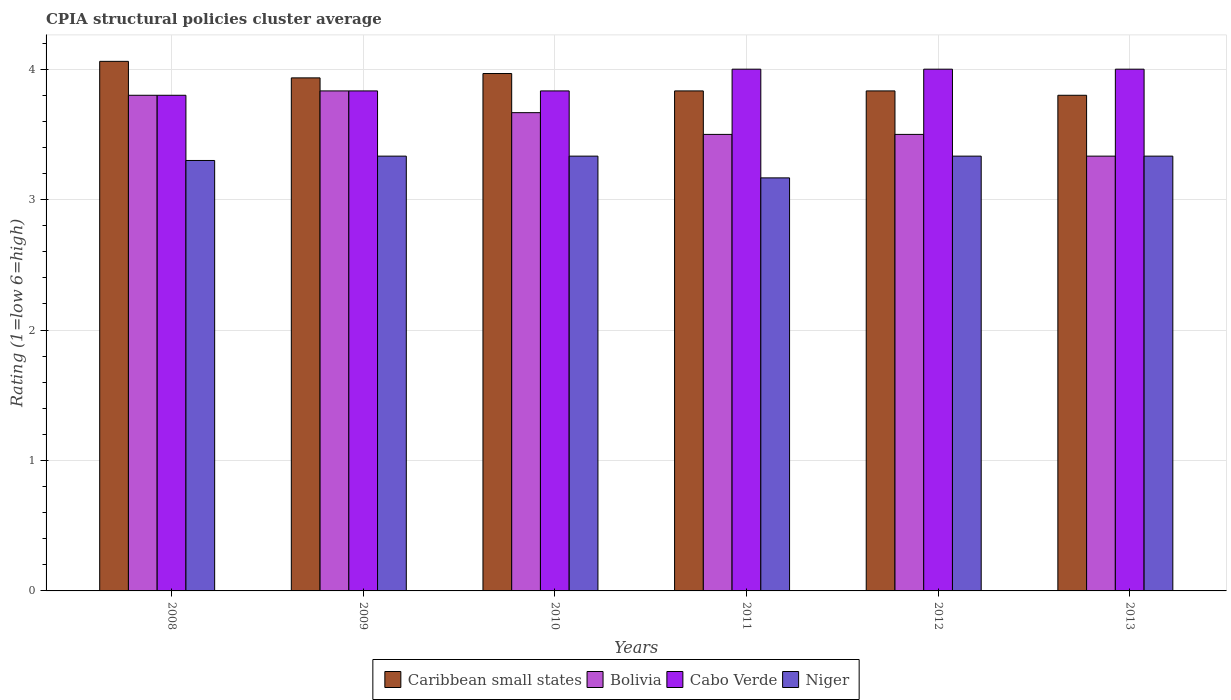How many different coloured bars are there?
Provide a short and direct response. 4. How many groups of bars are there?
Your answer should be compact. 6. Are the number of bars on each tick of the X-axis equal?
Keep it short and to the point. Yes. What is the label of the 3rd group of bars from the left?
Provide a short and direct response. 2010. In how many cases, is the number of bars for a given year not equal to the number of legend labels?
Your response must be concise. 0. What is the CPIA rating in Caribbean small states in 2011?
Your answer should be compact. 3.83. Across all years, what is the maximum CPIA rating in Niger?
Keep it short and to the point. 3.33. Across all years, what is the minimum CPIA rating in Bolivia?
Provide a short and direct response. 3.33. In which year was the CPIA rating in Caribbean small states maximum?
Keep it short and to the point. 2008. In which year was the CPIA rating in Caribbean small states minimum?
Your answer should be very brief. 2013. What is the total CPIA rating in Bolivia in the graph?
Your response must be concise. 21.63. What is the difference between the CPIA rating in Niger in 2008 and that in 2012?
Provide a succinct answer. -0.03. What is the difference between the CPIA rating in Caribbean small states in 2010 and the CPIA rating in Cabo Verde in 2013?
Your answer should be very brief. -0.03. What is the average CPIA rating in Bolivia per year?
Provide a succinct answer. 3.61. Is the CPIA rating in Caribbean small states in 2012 less than that in 2013?
Give a very brief answer. No. What is the difference between the highest and the lowest CPIA rating in Niger?
Make the answer very short. 0.17. In how many years, is the CPIA rating in Bolivia greater than the average CPIA rating in Bolivia taken over all years?
Your answer should be very brief. 3. Is the sum of the CPIA rating in Cabo Verde in 2010 and 2013 greater than the maximum CPIA rating in Niger across all years?
Your answer should be compact. Yes. What does the 2nd bar from the right in 2008 represents?
Your answer should be compact. Cabo Verde. Are all the bars in the graph horizontal?
Your answer should be very brief. No. Are the values on the major ticks of Y-axis written in scientific E-notation?
Ensure brevity in your answer.  No. Does the graph contain any zero values?
Give a very brief answer. No. How are the legend labels stacked?
Offer a terse response. Horizontal. What is the title of the graph?
Your response must be concise. CPIA structural policies cluster average. Does "Gabon" appear as one of the legend labels in the graph?
Provide a short and direct response. No. What is the label or title of the X-axis?
Provide a short and direct response. Years. What is the Rating (1=low 6=high) of Caribbean small states in 2008?
Your response must be concise. 4.06. What is the Rating (1=low 6=high) in Bolivia in 2008?
Keep it short and to the point. 3.8. What is the Rating (1=low 6=high) of Niger in 2008?
Your response must be concise. 3.3. What is the Rating (1=low 6=high) in Caribbean small states in 2009?
Provide a short and direct response. 3.93. What is the Rating (1=low 6=high) in Bolivia in 2009?
Offer a terse response. 3.83. What is the Rating (1=low 6=high) of Cabo Verde in 2009?
Offer a terse response. 3.83. What is the Rating (1=low 6=high) in Niger in 2009?
Your response must be concise. 3.33. What is the Rating (1=low 6=high) of Caribbean small states in 2010?
Your answer should be very brief. 3.97. What is the Rating (1=low 6=high) of Bolivia in 2010?
Provide a succinct answer. 3.67. What is the Rating (1=low 6=high) of Cabo Verde in 2010?
Ensure brevity in your answer.  3.83. What is the Rating (1=low 6=high) in Niger in 2010?
Your answer should be very brief. 3.33. What is the Rating (1=low 6=high) of Caribbean small states in 2011?
Keep it short and to the point. 3.83. What is the Rating (1=low 6=high) in Cabo Verde in 2011?
Give a very brief answer. 4. What is the Rating (1=low 6=high) of Niger in 2011?
Offer a terse response. 3.17. What is the Rating (1=low 6=high) in Caribbean small states in 2012?
Ensure brevity in your answer.  3.83. What is the Rating (1=low 6=high) of Niger in 2012?
Offer a terse response. 3.33. What is the Rating (1=low 6=high) of Caribbean small states in 2013?
Make the answer very short. 3.8. What is the Rating (1=low 6=high) in Bolivia in 2013?
Your answer should be compact. 3.33. What is the Rating (1=low 6=high) in Cabo Verde in 2013?
Provide a short and direct response. 4. What is the Rating (1=low 6=high) in Niger in 2013?
Keep it short and to the point. 3.33. Across all years, what is the maximum Rating (1=low 6=high) of Caribbean small states?
Make the answer very short. 4.06. Across all years, what is the maximum Rating (1=low 6=high) of Bolivia?
Give a very brief answer. 3.83. Across all years, what is the maximum Rating (1=low 6=high) in Cabo Verde?
Give a very brief answer. 4. Across all years, what is the maximum Rating (1=low 6=high) of Niger?
Give a very brief answer. 3.33. Across all years, what is the minimum Rating (1=low 6=high) in Bolivia?
Give a very brief answer. 3.33. Across all years, what is the minimum Rating (1=low 6=high) in Cabo Verde?
Your answer should be compact. 3.8. Across all years, what is the minimum Rating (1=low 6=high) of Niger?
Your answer should be compact. 3.17. What is the total Rating (1=low 6=high) in Caribbean small states in the graph?
Ensure brevity in your answer.  23.43. What is the total Rating (1=low 6=high) of Bolivia in the graph?
Offer a terse response. 21.63. What is the total Rating (1=low 6=high) in Cabo Verde in the graph?
Keep it short and to the point. 23.47. What is the total Rating (1=low 6=high) in Niger in the graph?
Ensure brevity in your answer.  19.8. What is the difference between the Rating (1=low 6=high) in Caribbean small states in 2008 and that in 2009?
Offer a terse response. 0.13. What is the difference between the Rating (1=low 6=high) of Bolivia in 2008 and that in 2009?
Make the answer very short. -0.03. What is the difference between the Rating (1=low 6=high) of Cabo Verde in 2008 and that in 2009?
Keep it short and to the point. -0.03. What is the difference between the Rating (1=low 6=high) in Niger in 2008 and that in 2009?
Keep it short and to the point. -0.03. What is the difference between the Rating (1=low 6=high) in Caribbean small states in 2008 and that in 2010?
Your answer should be compact. 0.09. What is the difference between the Rating (1=low 6=high) in Bolivia in 2008 and that in 2010?
Your response must be concise. 0.13. What is the difference between the Rating (1=low 6=high) of Cabo Verde in 2008 and that in 2010?
Your answer should be very brief. -0.03. What is the difference between the Rating (1=low 6=high) of Niger in 2008 and that in 2010?
Give a very brief answer. -0.03. What is the difference between the Rating (1=low 6=high) of Caribbean small states in 2008 and that in 2011?
Offer a very short reply. 0.23. What is the difference between the Rating (1=low 6=high) in Bolivia in 2008 and that in 2011?
Provide a short and direct response. 0.3. What is the difference between the Rating (1=low 6=high) of Niger in 2008 and that in 2011?
Ensure brevity in your answer.  0.13. What is the difference between the Rating (1=low 6=high) in Caribbean small states in 2008 and that in 2012?
Keep it short and to the point. 0.23. What is the difference between the Rating (1=low 6=high) of Bolivia in 2008 and that in 2012?
Provide a succinct answer. 0.3. What is the difference between the Rating (1=low 6=high) of Niger in 2008 and that in 2012?
Offer a terse response. -0.03. What is the difference between the Rating (1=low 6=high) of Caribbean small states in 2008 and that in 2013?
Make the answer very short. 0.26. What is the difference between the Rating (1=low 6=high) of Bolivia in 2008 and that in 2013?
Give a very brief answer. 0.47. What is the difference between the Rating (1=low 6=high) of Cabo Verde in 2008 and that in 2013?
Your answer should be compact. -0.2. What is the difference between the Rating (1=low 6=high) in Niger in 2008 and that in 2013?
Provide a short and direct response. -0.03. What is the difference between the Rating (1=low 6=high) of Caribbean small states in 2009 and that in 2010?
Give a very brief answer. -0.03. What is the difference between the Rating (1=low 6=high) of Bolivia in 2009 and that in 2010?
Offer a terse response. 0.17. What is the difference between the Rating (1=low 6=high) in Cabo Verde in 2009 and that in 2010?
Your answer should be very brief. 0. What is the difference between the Rating (1=low 6=high) in Niger in 2009 and that in 2011?
Provide a short and direct response. 0.17. What is the difference between the Rating (1=low 6=high) of Bolivia in 2009 and that in 2012?
Your answer should be compact. 0.33. What is the difference between the Rating (1=low 6=high) in Caribbean small states in 2009 and that in 2013?
Provide a short and direct response. 0.13. What is the difference between the Rating (1=low 6=high) in Cabo Verde in 2009 and that in 2013?
Offer a very short reply. -0.17. What is the difference between the Rating (1=low 6=high) of Caribbean small states in 2010 and that in 2011?
Your answer should be compact. 0.13. What is the difference between the Rating (1=low 6=high) in Bolivia in 2010 and that in 2011?
Make the answer very short. 0.17. What is the difference between the Rating (1=low 6=high) of Caribbean small states in 2010 and that in 2012?
Provide a short and direct response. 0.13. What is the difference between the Rating (1=low 6=high) of Bolivia in 2010 and that in 2012?
Your response must be concise. 0.17. What is the difference between the Rating (1=low 6=high) of Niger in 2010 and that in 2012?
Provide a succinct answer. 0. What is the difference between the Rating (1=low 6=high) in Caribbean small states in 2010 and that in 2013?
Offer a terse response. 0.17. What is the difference between the Rating (1=low 6=high) of Bolivia in 2010 and that in 2013?
Offer a very short reply. 0.33. What is the difference between the Rating (1=low 6=high) of Caribbean small states in 2011 and that in 2013?
Give a very brief answer. 0.03. What is the difference between the Rating (1=low 6=high) of Bolivia in 2011 and that in 2013?
Give a very brief answer. 0.17. What is the difference between the Rating (1=low 6=high) in Bolivia in 2012 and that in 2013?
Your answer should be compact. 0.17. What is the difference between the Rating (1=low 6=high) of Cabo Verde in 2012 and that in 2013?
Your response must be concise. 0. What is the difference between the Rating (1=low 6=high) of Niger in 2012 and that in 2013?
Give a very brief answer. 0. What is the difference between the Rating (1=low 6=high) of Caribbean small states in 2008 and the Rating (1=low 6=high) of Bolivia in 2009?
Your response must be concise. 0.23. What is the difference between the Rating (1=low 6=high) of Caribbean small states in 2008 and the Rating (1=low 6=high) of Cabo Verde in 2009?
Keep it short and to the point. 0.23. What is the difference between the Rating (1=low 6=high) of Caribbean small states in 2008 and the Rating (1=low 6=high) of Niger in 2009?
Your answer should be very brief. 0.73. What is the difference between the Rating (1=low 6=high) of Bolivia in 2008 and the Rating (1=low 6=high) of Cabo Verde in 2009?
Your answer should be very brief. -0.03. What is the difference between the Rating (1=low 6=high) of Bolivia in 2008 and the Rating (1=low 6=high) of Niger in 2009?
Provide a succinct answer. 0.47. What is the difference between the Rating (1=low 6=high) in Cabo Verde in 2008 and the Rating (1=low 6=high) in Niger in 2009?
Provide a succinct answer. 0.47. What is the difference between the Rating (1=low 6=high) in Caribbean small states in 2008 and the Rating (1=low 6=high) in Bolivia in 2010?
Ensure brevity in your answer.  0.39. What is the difference between the Rating (1=low 6=high) in Caribbean small states in 2008 and the Rating (1=low 6=high) in Cabo Verde in 2010?
Ensure brevity in your answer.  0.23. What is the difference between the Rating (1=low 6=high) of Caribbean small states in 2008 and the Rating (1=low 6=high) of Niger in 2010?
Give a very brief answer. 0.73. What is the difference between the Rating (1=low 6=high) in Bolivia in 2008 and the Rating (1=low 6=high) in Cabo Verde in 2010?
Ensure brevity in your answer.  -0.03. What is the difference between the Rating (1=low 6=high) of Bolivia in 2008 and the Rating (1=low 6=high) of Niger in 2010?
Your answer should be compact. 0.47. What is the difference between the Rating (1=low 6=high) of Cabo Verde in 2008 and the Rating (1=low 6=high) of Niger in 2010?
Your answer should be very brief. 0.47. What is the difference between the Rating (1=low 6=high) of Caribbean small states in 2008 and the Rating (1=low 6=high) of Bolivia in 2011?
Your answer should be compact. 0.56. What is the difference between the Rating (1=low 6=high) in Caribbean small states in 2008 and the Rating (1=low 6=high) in Cabo Verde in 2011?
Keep it short and to the point. 0.06. What is the difference between the Rating (1=low 6=high) in Caribbean small states in 2008 and the Rating (1=low 6=high) in Niger in 2011?
Provide a short and direct response. 0.89. What is the difference between the Rating (1=low 6=high) of Bolivia in 2008 and the Rating (1=low 6=high) of Cabo Verde in 2011?
Your response must be concise. -0.2. What is the difference between the Rating (1=low 6=high) of Bolivia in 2008 and the Rating (1=low 6=high) of Niger in 2011?
Give a very brief answer. 0.63. What is the difference between the Rating (1=low 6=high) of Cabo Verde in 2008 and the Rating (1=low 6=high) of Niger in 2011?
Give a very brief answer. 0.63. What is the difference between the Rating (1=low 6=high) of Caribbean small states in 2008 and the Rating (1=low 6=high) of Bolivia in 2012?
Provide a succinct answer. 0.56. What is the difference between the Rating (1=low 6=high) of Caribbean small states in 2008 and the Rating (1=low 6=high) of Niger in 2012?
Make the answer very short. 0.73. What is the difference between the Rating (1=low 6=high) in Bolivia in 2008 and the Rating (1=low 6=high) in Cabo Verde in 2012?
Offer a very short reply. -0.2. What is the difference between the Rating (1=low 6=high) in Bolivia in 2008 and the Rating (1=low 6=high) in Niger in 2012?
Ensure brevity in your answer.  0.47. What is the difference between the Rating (1=low 6=high) of Cabo Verde in 2008 and the Rating (1=low 6=high) of Niger in 2012?
Your answer should be compact. 0.47. What is the difference between the Rating (1=low 6=high) of Caribbean small states in 2008 and the Rating (1=low 6=high) of Bolivia in 2013?
Give a very brief answer. 0.73. What is the difference between the Rating (1=low 6=high) of Caribbean small states in 2008 and the Rating (1=low 6=high) of Cabo Verde in 2013?
Make the answer very short. 0.06. What is the difference between the Rating (1=low 6=high) in Caribbean small states in 2008 and the Rating (1=low 6=high) in Niger in 2013?
Your response must be concise. 0.73. What is the difference between the Rating (1=low 6=high) in Bolivia in 2008 and the Rating (1=low 6=high) in Niger in 2013?
Keep it short and to the point. 0.47. What is the difference between the Rating (1=low 6=high) of Cabo Verde in 2008 and the Rating (1=low 6=high) of Niger in 2013?
Offer a very short reply. 0.47. What is the difference between the Rating (1=low 6=high) in Caribbean small states in 2009 and the Rating (1=low 6=high) in Bolivia in 2010?
Keep it short and to the point. 0.27. What is the difference between the Rating (1=low 6=high) of Bolivia in 2009 and the Rating (1=low 6=high) of Cabo Verde in 2010?
Ensure brevity in your answer.  0. What is the difference between the Rating (1=low 6=high) in Cabo Verde in 2009 and the Rating (1=low 6=high) in Niger in 2010?
Your answer should be very brief. 0.5. What is the difference between the Rating (1=low 6=high) of Caribbean small states in 2009 and the Rating (1=low 6=high) of Bolivia in 2011?
Your answer should be very brief. 0.43. What is the difference between the Rating (1=low 6=high) of Caribbean small states in 2009 and the Rating (1=low 6=high) of Cabo Verde in 2011?
Offer a terse response. -0.07. What is the difference between the Rating (1=low 6=high) in Caribbean small states in 2009 and the Rating (1=low 6=high) in Niger in 2011?
Give a very brief answer. 0.77. What is the difference between the Rating (1=low 6=high) in Bolivia in 2009 and the Rating (1=low 6=high) in Cabo Verde in 2011?
Keep it short and to the point. -0.17. What is the difference between the Rating (1=low 6=high) in Caribbean small states in 2009 and the Rating (1=low 6=high) in Bolivia in 2012?
Provide a short and direct response. 0.43. What is the difference between the Rating (1=low 6=high) in Caribbean small states in 2009 and the Rating (1=low 6=high) in Cabo Verde in 2012?
Your response must be concise. -0.07. What is the difference between the Rating (1=low 6=high) in Caribbean small states in 2009 and the Rating (1=low 6=high) in Niger in 2012?
Your answer should be very brief. 0.6. What is the difference between the Rating (1=low 6=high) in Bolivia in 2009 and the Rating (1=low 6=high) in Cabo Verde in 2012?
Provide a succinct answer. -0.17. What is the difference between the Rating (1=low 6=high) of Bolivia in 2009 and the Rating (1=low 6=high) of Niger in 2012?
Offer a very short reply. 0.5. What is the difference between the Rating (1=low 6=high) in Cabo Verde in 2009 and the Rating (1=low 6=high) in Niger in 2012?
Provide a short and direct response. 0.5. What is the difference between the Rating (1=low 6=high) of Caribbean small states in 2009 and the Rating (1=low 6=high) of Bolivia in 2013?
Your answer should be very brief. 0.6. What is the difference between the Rating (1=low 6=high) in Caribbean small states in 2009 and the Rating (1=low 6=high) in Cabo Verde in 2013?
Make the answer very short. -0.07. What is the difference between the Rating (1=low 6=high) in Cabo Verde in 2009 and the Rating (1=low 6=high) in Niger in 2013?
Your response must be concise. 0.5. What is the difference between the Rating (1=low 6=high) of Caribbean small states in 2010 and the Rating (1=low 6=high) of Bolivia in 2011?
Offer a very short reply. 0.47. What is the difference between the Rating (1=low 6=high) in Caribbean small states in 2010 and the Rating (1=low 6=high) in Cabo Verde in 2011?
Ensure brevity in your answer.  -0.03. What is the difference between the Rating (1=low 6=high) in Caribbean small states in 2010 and the Rating (1=low 6=high) in Niger in 2011?
Give a very brief answer. 0.8. What is the difference between the Rating (1=low 6=high) in Bolivia in 2010 and the Rating (1=low 6=high) in Niger in 2011?
Your response must be concise. 0.5. What is the difference between the Rating (1=low 6=high) of Caribbean small states in 2010 and the Rating (1=low 6=high) of Bolivia in 2012?
Your answer should be very brief. 0.47. What is the difference between the Rating (1=low 6=high) in Caribbean small states in 2010 and the Rating (1=low 6=high) in Cabo Verde in 2012?
Ensure brevity in your answer.  -0.03. What is the difference between the Rating (1=low 6=high) of Caribbean small states in 2010 and the Rating (1=low 6=high) of Niger in 2012?
Offer a very short reply. 0.63. What is the difference between the Rating (1=low 6=high) in Bolivia in 2010 and the Rating (1=low 6=high) in Cabo Verde in 2012?
Keep it short and to the point. -0.33. What is the difference between the Rating (1=low 6=high) in Cabo Verde in 2010 and the Rating (1=low 6=high) in Niger in 2012?
Your answer should be very brief. 0.5. What is the difference between the Rating (1=low 6=high) in Caribbean small states in 2010 and the Rating (1=low 6=high) in Bolivia in 2013?
Provide a succinct answer. 0.63. What is the difference between the Rating (1=low 6=high) of Caribbean small states in 2010 and the Rating (1=low 6=high) of Cabo Verde in 2013?
Ensure brevity in your answer.  -0.03. What is the difference between the Rating (1=low 6=high) of Caribbean small states in 2010 and the Rating (1=low 6=high) of Niger in 2013?
Ensure brevity in your answer.  0.63. What is the difference between the Rating (1=low 6=high) of Bolivia in 2010 and the Rating (1=low 6=high) of Cabo Verde in 2013?
Ensure brevity in your answer.  -0.33. What is the difference between the Rating (1=low 6=high) of Cabo Verde in 2010 and the Rating (1=low 6=high) of Niger in 2013?
Your answer should be very brief. 0.5. What is the difference between the Rating (1=low 6=high) in Caribbean small states in 2011 and the Rating (1=low 6=high) in Cabo Verde in 2012?
Give a very brief answer. -0.17. What is the difference between the Rating (1=low 6=high) in Bolivia in 2011 and the Rating (1=low 6=high) in Cabo Verde in 2012?
Offer a terse response. -0.5. What is the difference between the Rating (1=low 6=high) in Bolivia in 2011 and the Rating (1=low 6=high) in Niger in 2012?
Provide a succinct answer. 0.17. What is the difference between the Rating (1=low 6=high) of Cabo Verde in 2011 and the Rating (1=low 6=high) of Niger in 2012?
Your answer should be very brief. 0.67. What is the difference between the Rating (1=low 6=high) in Caribbean small states in 2011 and the Rating (1=low 6=high) in Bolivia in 2013?
Provide a short and direct response. 0.5. What is the difference between the Rating (1=low 6=high) in Cabo Verde in 2011 and the Rating (1=low 6=high) in Niger in 2013?
Provide a succinct answer. 0.67. What is the difference between the Rating (1=low 6=high) of Caribbean small states in 2012 and the Rating (1=low 6=high) of Niger in 2013?
Give a very brief answer. 0.5. What is the average Rating (1=low 6=high) in Caribbean small states per year?
Your answer should be very brief. 3.9. What is the average Rating (1=low 6=high) of Bolivia per year?
Make the answer very short. 3.61. What is the average Rating (1=low 6=high) of Cabo Verde per year?
Keep it short and to the point. 3.91. In the year 2008, what is the difference between the Rating (1=low 6=high) in Caribbean small states and Rating (1=low 6=high) in Bolivia?
Your answer should be very brief. 0.26. In the year 2008, what is the difference between the Rating (1=low 6=high) of Caribbean small states and Rating (1=low 6=high) of Cabo Verde?
Offer a very short reply. 0.26. In the year 2008, what is the difference between the Rating (1=low 6=high) of Caribbean small states and Rating (1=low 6=high) of Niger?
Offer a very short reply. 0.76. In the year 2008, what is the difference between the Rating (1=low 6=high) of Bolivia and Rating (1=low 6=high) of Niger?
Offer a very short reply. 0.5. In the year 2008, what is the difference between the Rating (1=low 6=high) in Cabo Verde and Rating (1=low 6=high) in Niger?
Give a very brief answer. 0.5. In the year 2009, what is the difference between the Rating (1=low 6=high) in Caribbean small states and Rating (1=low 6=high) in Bolivia?
Your response must be concise. 0.1. In the year 2009, what is the difference between the Rating (1=low 6=high) of Caribbean small states and Rating (1=low 6=high) of Cabo Verde?
Keep it short and to the point. 0.1. In the year 2009, what is the difference between the Rating (1=low 6=high) in Bolivia and Rating (1=low 6=high) in Cabo Verde?
Keep it short and to the point. 0. In the year 2009, what is the difference between the Rating (1=low 6=high) in Bolivia and Rating (1=low 6=high) in Niger?
Provide a succinct answer. 0.5. In the year 2009, what is the difference between the Rating (1=low 6=high) in Cabo Verde and Rating (1=low 6=high) in Niger?
Your answer should be very brief. 0.5. In the year 2010, what is the difference between the Rating (1=low 6=high) in Caribbean small states and Rating (1=low 6=high) in Bolivia?
Keep it short and to the point. 0.3. In the year 2010, what is the difference between the Rating (1=low 6=high) of Caribbean small states and Rating (1=low 6=high) of Cabo Verde?
Offer a very short reply. 0.13. In the year 2010, what is the difference between the Rating (1=low 6=high) of Caribbean small states and Rating (1=low 6=high) of Niger?
Offer a terse response. 0.63. In the year 2010, what is the difference between the Rating (1=low 6=high) in Bolivia and Rating (1=low 6=high) in Niger?
Provide a short and direct response. 0.33. In the year 2010, what is the difference between the Rating (1=low 6=high) in Cabo Verde and Rating (1=low 6=high) in Niger?
Provide a succinct answer. 0.5. In the year 2011, what is the difference between the Rating (1=low 6=high) in Caribbean small states and Rating (1=low 6=high) in Bolivia?
Provide a succinct answer. 0.33. In the year 2011, what is the difference between the Rating (1=low 6=high) in Caribbean small states and Rating (1=low 6=high) in Cabo Verde?
Your response must be concise. -0.17. In the year 2011, what is the difference between the Rating (1=low 6=high) of Caribbean small states and Rating (1=low 6=high) of Niger?
Your response must be concise. 0.67. In the year 2011, what is the difference between the Rating (1=low 6=high) of Bolivia and Rating (1=low 6=high) of Niger?
Provide a short and direct response. 0.33. In the year 2011, what is the difference between the Rating (1=low 6=high) in Cabo Verde and Rating (1=low 6=high) in Niger?
Offer a terse response. 0.83. In the year 2012, what is the difference between the Rating (1=low 6=high) in Caribbean small states and Rating (1=low 6=high) in Bolivia?
Give a very brief answer. 0.33. In the year 2012, what is the difference between the Rating (1=low 6=high) of Bolivia and Rating (1=low 6=high) of Cabo Verde?
Ensure brevity in your answer.  -0.5. In the year 2012, what is the difference between the Rating (1=low 6=high) in Cabo Verde and Rating (1=low 6=high) in Niger?
Provide a short and direct response. 0.67. In the year 2013, what is the difference between the Rating (1=low 6=high) in Caribbean small states and Rating (1=low 6=high) in Bolivia?
Make the answer very short. 0.47. In the year 2013, what is the difference between the Rating (1=low 6=high) in Caribbean small states and Rating (1=low 6=high) in Cabo Verde?
Your answer should be very brief. -0.2. In the year 2013, what is the difference between the Rating (1=low 6=high) of Caribbean small states and Rating (1=low 6=high) of Niger?
Provide a short and direct response. 0.47. In the year 2013, what is the difference between the Rating (1=low 6=high) of Bolivia and Rating (1=low 6=high) of Cabo Verde?
Give a very brief answer. -0.67. In the year 2013, what is the difference between the Rating (1=low 6=high) of Bolivia and Rating (1=low 6=high) of Niger?
Give a very brief answer. 0. In the year 2013, what is the difference between the Rating (1=low 6=high) of Cabo Verde and Rating (1=low 6=high) of Niger?
Provide a succinct answer. 0.67. What is the ratio of the Rating (1=low 6=high) of Caribbean small states in 2008 to that in 2009?
Offer a very short reply. 1.03. What is the ratio of the Rating (1=low 6=high) of Cabo Verde in 2008 to that in 2009?
Your response must be concise. 0.99. What is the ratio of the Rating (1=low 6=high) of Caribbean small states in 2008 to that in 2010?
Your answer should be compact. 1.02. What is the ratio of the Rating (1=low 6=high) in Bolivia in 2008 to that in 2010?
Provide a succinct answer. 1.04. What is the ratio of the Rating (1=low 6=high) in Caribbean small states in 2008 to that in 2011?
Provide a short and direct response. 1.06. What is the ratio of the Rating (1=low 6=high) in Bolivia in 2008 to that in 2011?
Ensure brevity in your answer.  1.09. What is the ratio of the Rating (1=low 6=high) in Niger in 2008 to that in 2011?
Your answer should be very brief. 1.04. What is the ratio of the Rating (1=low 6=high) in Caribbean small states in 2008 to that in 2012?
Keep it short and to the point. 1.06. What is the ratio of the Rating (1=low 6=high) of Bolivia in 2008 to that in 2012?
Ensure brevity in your answer.  1.09. What is the ratio of the Rating (1=low 6=high) of Niger in 2008 to that in 2012?
Provide a short and direct response. 0.99. What is the ratio of the Rating (1=low 6=high) in Caribbean small states in 2008 to that in 2013?
Offer a terse response. 1.07. What is the ratio of the Rating (1=low 6=high) of Bolivia in 2008 to that in 2013?
Your response must be concise. 1.14. What is the ratio of the Rating (1=low 6=high) of Cabo Verde in 2008 to that in 2013?
Give a very brief answer. 0.95. What is the ratio of the Rating (1=low 6=high) of Bolivia in 2009 to that in 2010?
Offer a terse response. 1.05. What is the ratio of the Rating (1=low 6=high) of Cabo Verde in 2009 to that in 2010?
Your answer should be compact. 1. What is the ratio of the Rating (1=low 6=high) of Caribbean small states in 2009 to that in 2011?
Your answer should be compact. 1.03. What is the ratio of the Rating (1=low 6=high) in Bolivia in 2009 to that in 2011?
Give a very brief answer. 1.1. What is the ratio of the Rating (1=low 6=high) in Cabo Verde in 2009 to that in 2011?
Provide a succinct answer. 0.96. What is the ratio of the Rating (1=low 6=high) in Niger in 2009 to that in 2011?
Offer a terse response. 1.05. What is the ratio of the Rating (1=low 6=high) in Caribbean small states in 2009 to that in 2012?
Keep it short and to the point. 1.03. What is the ratio of the Rating (1=low 6=high) of Bolivia in 2009 to that in 2012?
Give a very brief answer. 1.1. What is the ratio of the Rating (1=low 6=high) in Niger in 2009 to that in 2012?
Your answer should be compact. 1. What is the ratio of the Rating (1=low 6=high) in Caribbean small states in 2009 to that in 2013?
Your response must be concise. 1.04. What is the ratio of the Rating (1=low 6=high) in Bolivia in 2009 to that in 2013?
Your answer should be very brief. 1.15. What is the ratio of the Rating (1=low 6=high) in Cabo Verde in 2009 to that in 2013?
Keep it short and to the point. 0.96. What is the ratio of the Rating (1=low 6=high) in Niger in 2009 to that in 2013?
Keep it short and to the point. 1. What is the ratio of the Rating (1=low 6=high) in Caribbean small states in 2010 to that in 2011?
Your answer should be compact. 1.03. What is the ratio of the Rating (1=low 6=high) of Bolivia in 2010 to that in 2011?
Offer a very short reply. 1.05. What is the ratio of the Rating (1=low 6=high) in Cabo Verde in 2010 to that in 2011?
Provide a short and direct response. 0.96. What is the ratio of the Rating (1=low 6=high) in Niger in 2010 to that in 2011?
Your response must be concise. 1.05. What is the ratio of the Rating (1=low 6=high) of Caribbean small states in 2010 to that in 2012?
Offer a terse response. 1.03. What is the ratio of the Rating (1=low 6=high) in Bolivia in 2010 to that in 2012?
Give a very brief answer. 1.05. What is the ratio of the Rating (1=low 6=high) of Caribbean small states in 2010 to that in 2013?
Make the answer very short. 1.04. What is the ratio of the Rating (1=low 6=high) in Bolivia in 2010 to that in 2013?
Keep it short and to the point. 1.1. What is the ratio of the Rating (1=low 6=high) of Cabo Verde in 2010 to that in 2013?
Your answer should be very brief. 0.96. What is the ratio of the Rating (1=low 6=high) of Niger in 2010 to that in 2013?
Provide a succinct answer. 1. What is the ratio of the Rating (1=low 6=high) in Bolivia in 2011 to that in 2012?
Provide a succinct answer. 1. What is the ratio of the Rating (1=low 6=high) in Cabo Verde in 2011 to that in 2012?
Your answer should be compact. 1. What is the ratio of the Rating (1=low 6=high) in Niger in 2011 to that in 2012?
Your answer should be compact. 0.95. What is the ratio of the Rating (1=low 6=high) in Caribbean small states in 2011 to that in 2013?
Your answer should be very brief. 1.01. What is the ratio of the Rating (1=low 6=high) in Bolivia in 2011 to that in 2013?
Make the answer very short. 1.05. What is the ratio of the Rating (1=low 6=high) of Cabo Verde in 2011 to that in 2013?
Provide a short and direct response. 1. What is the ratio of the Rating (1=low 6=high) in Caribbean small states in 2012 to that in 2013?
Ensure brevity in your answer.  1.01. What is the ratio of the Rating (1=low 6=high) of Niger in 2012 to that in 2013?
Provide a succinct answer. 1. What is the difference between the highest and the second highest Rating (1=low 6=high) in Caribbean small states?
Your response must be concise. 0.09. What is the difference between the highest and the second highest Rating (1=low 6=high) of Cabo Verde?
Offer a terse response. 0. What is the difference between the highest and the lowest Rating (1=low 6=high) in Caribbean small states?
Make the answer very short. 0.26. What is the difference between the highest and the lowest Rating (1=low 6=high) of Bolivia?
Provide a succinct answer. 0.5. What is the difference between the highest and the lowest Rating (1=low 6=high) in Cabo Verde?
Offer a terse response. 0.2. 